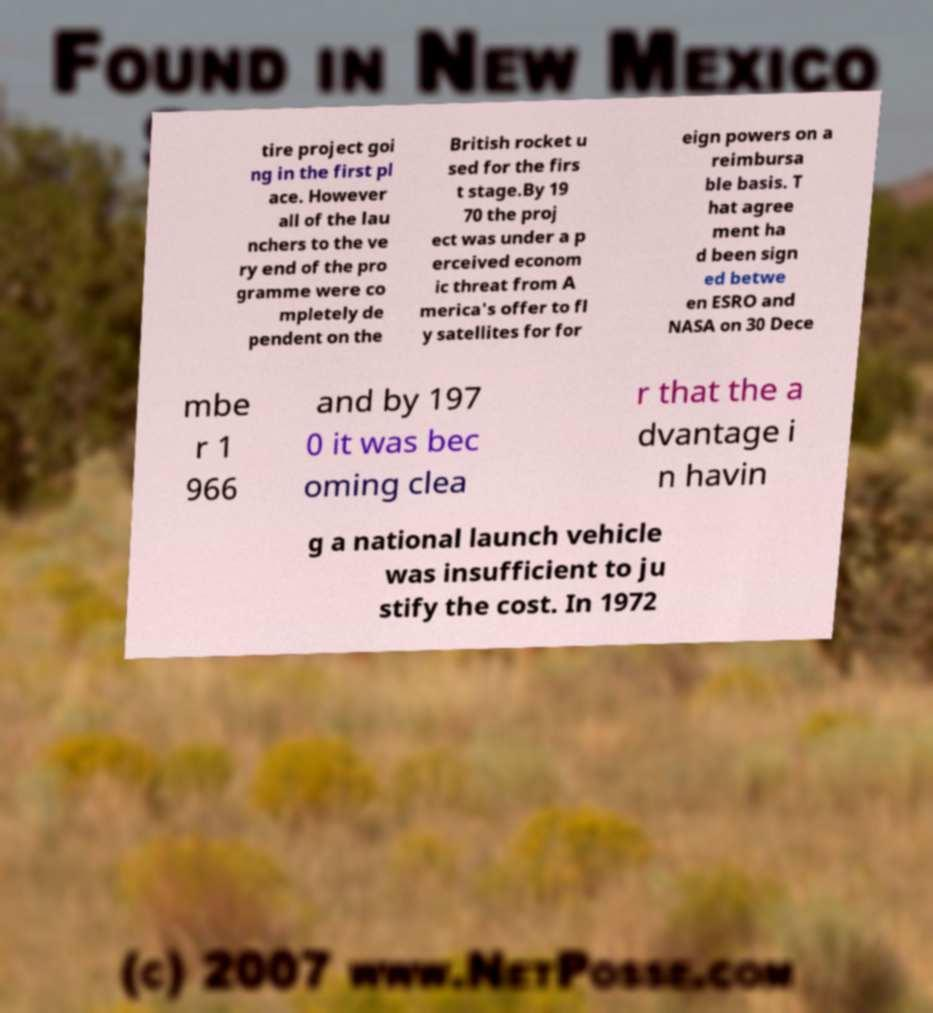What messages or text are displayed in this image? I need them in a readable, typed format. tire project goi ng in the first pl ace. However all of the lau nchers to the ve ry end of the pro gramme were co mpletely de pendent on the British rocket u sed for the firs t stage.By 19 70 the proj ect was under a p erceived econom ic threat from A merica's offer to fl y satellites for for eign powers on a reimbursa ble basis. T hat agree ment ha d been sign ed betwe en ESRO and NASA on 30 Dece mbe r 1 966 and by 197 0 it was bec oming clea r that the a dvantage i n havin g a national launch vehicle was insufficient to ju stify the cost. In 1972 